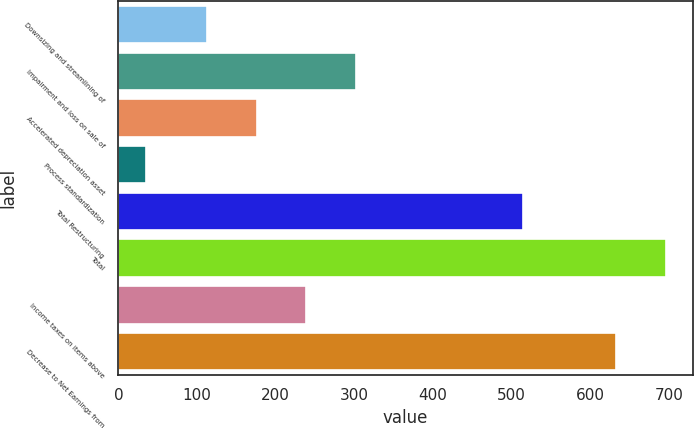Convert chart to OTSL. <chart><loc_0><loc_0><loc_500><loc_500><bar_chart><fcel>Downsizing and streamlining of<fcel>Impairment and loss on sale of<fcel>Accelerated depreciation asset<fcel>Process standardization<fcel>Total Restructuring<fcel>Total<fcel>Income taxes on items above<fcel>Decrease to Net Earnings from<nl><fcel>113<fcel>302<fcel>176<fcel>35<fcel>515<fcel>696<fcel>239<fcel>633<nl></chart> 